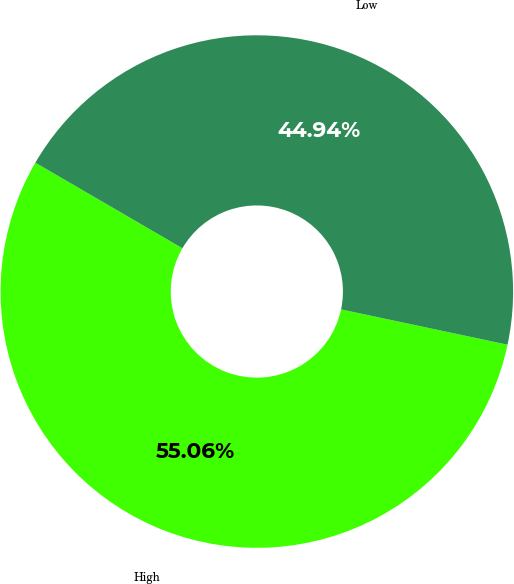<chart> <loc_0><loc_0><loc_500><loc_500><pie_chart><fcel>High<fcel>Low<nl><fcel>55.06%<fcel>44.94%<nl></chart> 